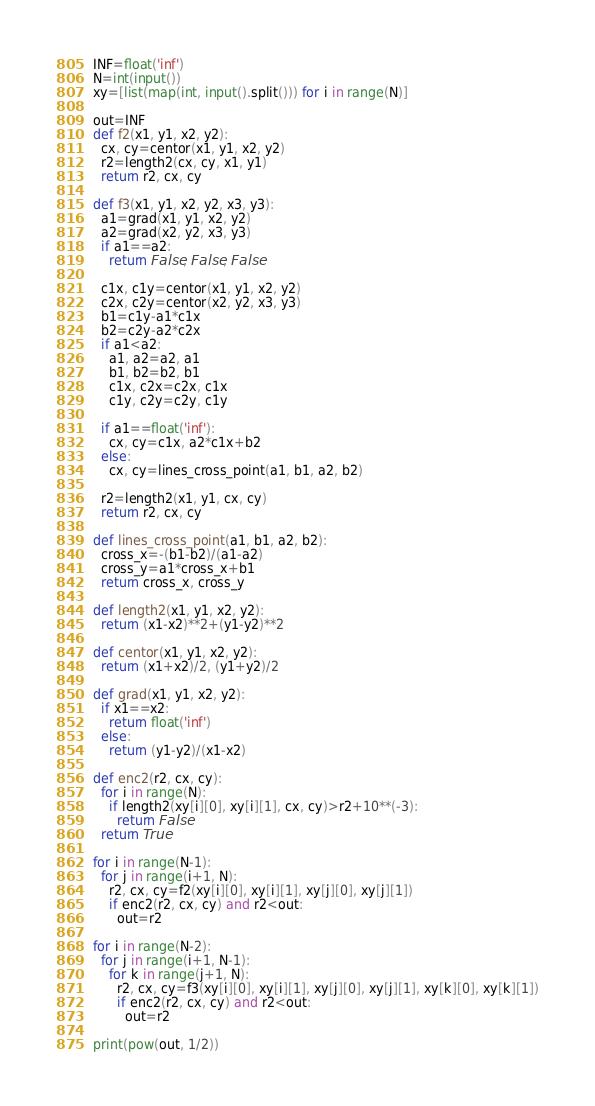<code> <loc_0><loc_0><loc_500><loc_500><_Python_>INF=float('inf')
N=int(input())
xy=[list(map(int, input().split())) for i in range(N)]

out=INF
def f2(x1, y1, x2, y2):
  cx, cy=centor(x1, y1, x2, y2)
  r2=length2(cx, cy, x1, y1)
  return r2, cx, cy

def f3(x1, y1, x2, y2, x3, y3):
  a1=grad(x1, y1, x2, y2)
  a2=grad(x2, y2, x3, y3)
  if a1==a2:
    return False, False, False
  
  c1x, c1y=centor(x1, y1, x2, y2)
  c2x, c2y=centor(x2, y2, x3, y3)
  b1=c1y-a1*c1x
  b2=c2y-a2*c2x
  if a1<a2:
    a1, a2=a2, a1
    b1, b2=b2, b1
    c1x, c2x=c2x, c1x
    c1y, c2y=c2y, c1y
    
  if a1==float('inf'):
    cx, cy=c1x, a2*c1x+b2
  else:
    cx, cy=lines_cross_point(a1, b1, a2, b2)
  
  r2=length2(x1, y1, cx, cy)
  return r2, cx, cy
  
def lines_cross_point(a1, b1, a2, b2):
  cross_x=-(b1-b2)/(a1-a2)
  cross_y=a1*cross_x+b1
  return cross_x, cross_y

def length2(x1, y1, x2, y2):
  return (x1-x2)**2+(y1-y2)**2

def centor(x1, y1, x2, y2):
  return (x1+x2)/2, (y1+y2)/2

def grad(x1, y1, x2, y2):
  if x1==x2:
    return float('inf')
  else:
    return (y1-y2)/(x1-x2)
  
def enc2(r2, cx, cy):
  for i in range(N):
    if length2(xy[i][0], xy[i][1], cx, cy)>r2+10**(-3):
      return False
  return True

for i in range(N-1):
  for j in range(i+1, N):
    r2, cx, cy=f2(xy[i][0], xy[i][1], xy[j][0], xy[j][1])
    if enc2(r2, cx, cy) and r2<out:
      out=r2
      
for i in range(N-2):
  for j in range(i+1, N-1):
    for k in range(j+1, N):
      r2, cx, cy=f3(xy[i][0], xy[i][1], xy[j][0], xy[j][1], xy[k][0], xy[k][1])
      if enc2(r2, cx, cy) and r2<out:
        out=r2
        
print(pow(out, 1/2))</code> 